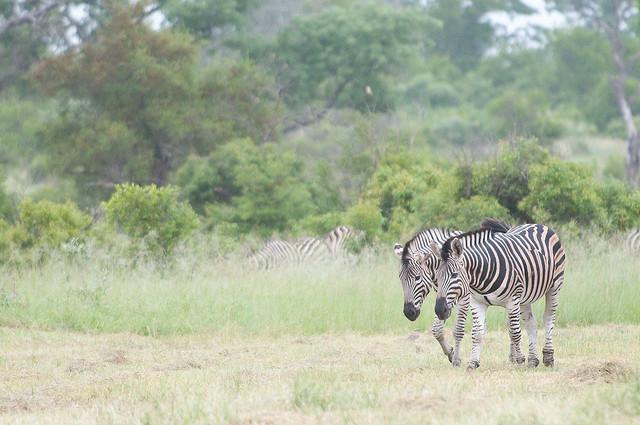Is there plenty of grass for the zebra to eat?
Keep it brief. Yes. Is there a fence?
Concise answer only. No. Is the grass high?
Concise answer only. Yes. Is the zebra in the zoo?
Be succinct. No. Are the zebras in the jungle?
Be succinct. No. How many zebras can you see?
Keep it brief. 4. What continent do these animals originate from?
Give a very brief answer. Africa. Does the tree have dead branches?
Give a very brief answer. No. 